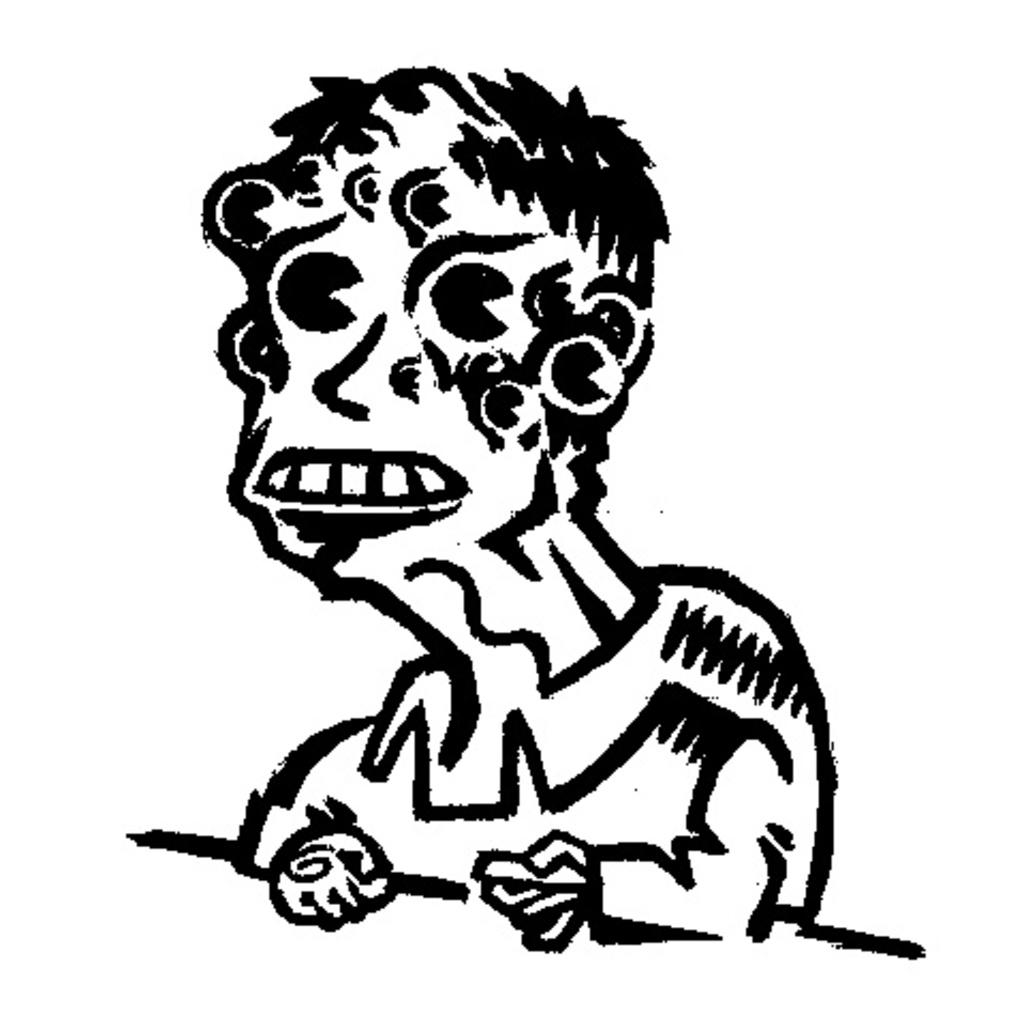What is the main subject of the image? The main subject of the image is a drawing. What can be said about the color scheme of the image? The image is black and white in color. What type of work is being done in the image? There is no indication of any work being done in the image, as it features a drawing in black and white. What month is it in the image? The image does not provide any information about the month or time of year. 